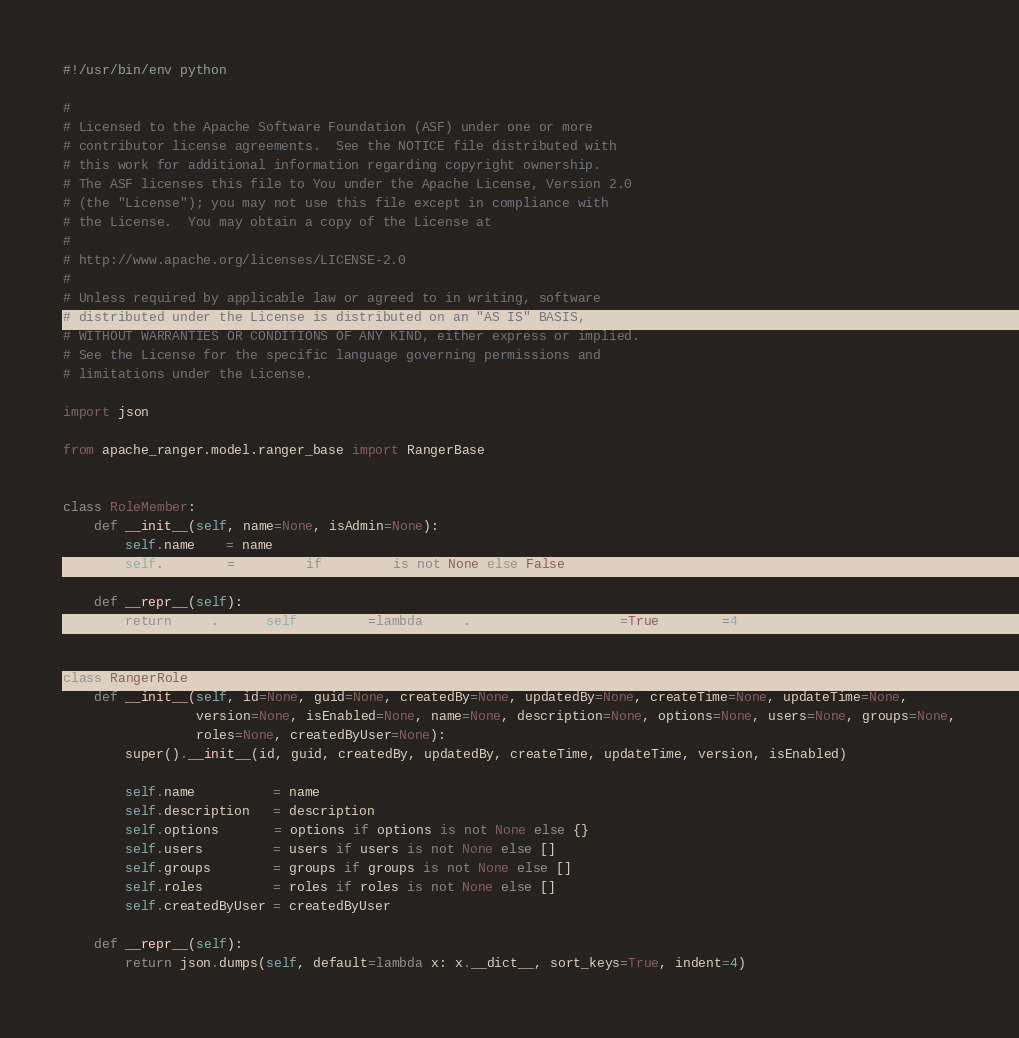<code> <loc_0><loc_0><loc_500><loc_500><_Python_>#!/usr/bin/env python

#
# Licensed to the Apache Software Foundation (ASF) under one or more
# contributor license agreements.  See the NOTICE file distributed with
# this work for additional information regarding copyright ownership.
# The ASF licenses this file to You under the Apache License, Version 2.0
# (the "License"); you may not use this file except in compliance with
# the License.  You may obtain a copy of the License at
#
# http://www.apache.org/licenses/LICENSE-2.0
#
# Unless required by applicable law or agreed to in writing, software
# distributed under the License is distributed on an "AS IS" BASIS,
# WITHOUT WARRANTIES OR CONDITIONS OF ANY KIND, either express or implied.
# See the License for the specific language governing permissions and
# limitations under the License.

import json

from apache_ranger.model.ranger_base import RangerBase


class RoleMember:
    def __init__(self, name=None, isAdmin=None):
        self.name    = name
        self.isAdmin = isAdmin if isAdmin is not None else False

    def __repr__(self):
        return json.dumps(self, default=lambda x: x.__dict__, sort_keys=True, indent=4)


class RangerRole(RangerBase):
    def __init__(self, id=None, guid=None, createdBy=None, updatedBy=None, createTime=None, updateTime=None,
                 version=None, isEnabled=None, name=None, description=None, options=None, users=None, groups=None,
                 roles=None, createdByUser=None):
        super().__init__(id, guid, createdBy, updatedBy, createTime, updateTime, version, isEnabled)

        self.name          = name
        self.description   = description
        self.options       = options if options is not None else {}
        self.users         = users if users is not None else []
        self.groups        = groups if groups is not None else []
        self.roles         = roles if roles is not None else []
        self.createdByUser = createdByUser

    def __repr__(self):
        return json.dumps(self, default=lambda x: x.__dict__, sort_keys=True, indent=4)
</code> 